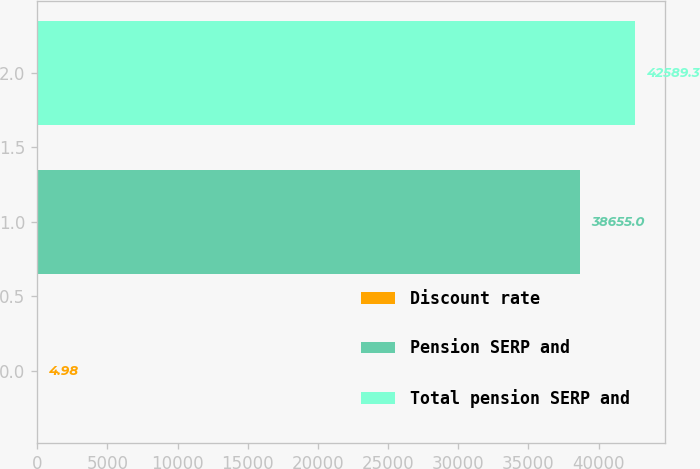Convert chart. <chart><loc_0><loc_0><loc_500><loc_500><bar_chart><fcel>Discount rate<fcel>Pension SERP and<fcel>Total pension SERP and<nl><fcel>4.98<fcel>38655<fcel>42589.3<nl></chart> 